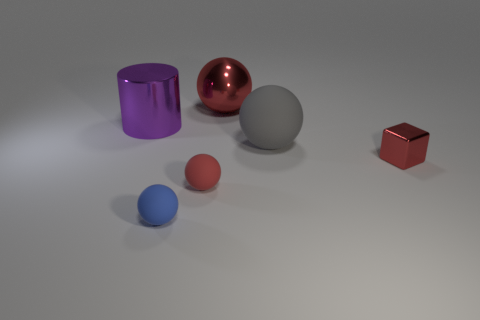Subtract 1 spheres. How many spheres are left? 3 Subtract all green spheres. Subtract all cyan cylinders. How many spheres are left? 4 Add 3 tiny cubes. How many objects exist? 9 Subtract all blocks. How many objects are left? 5 Subtract all tiny red spheres. Subtract all large purple shiny cylinders. How many objects are left? 4 Add 4 big rubber balls. How many big rubber balls are left? 5 Add 6 tiny red rubber things. How many tiny red rubber things exist? 7 Subtract 0 purple spheres. How many objects are left? 6 